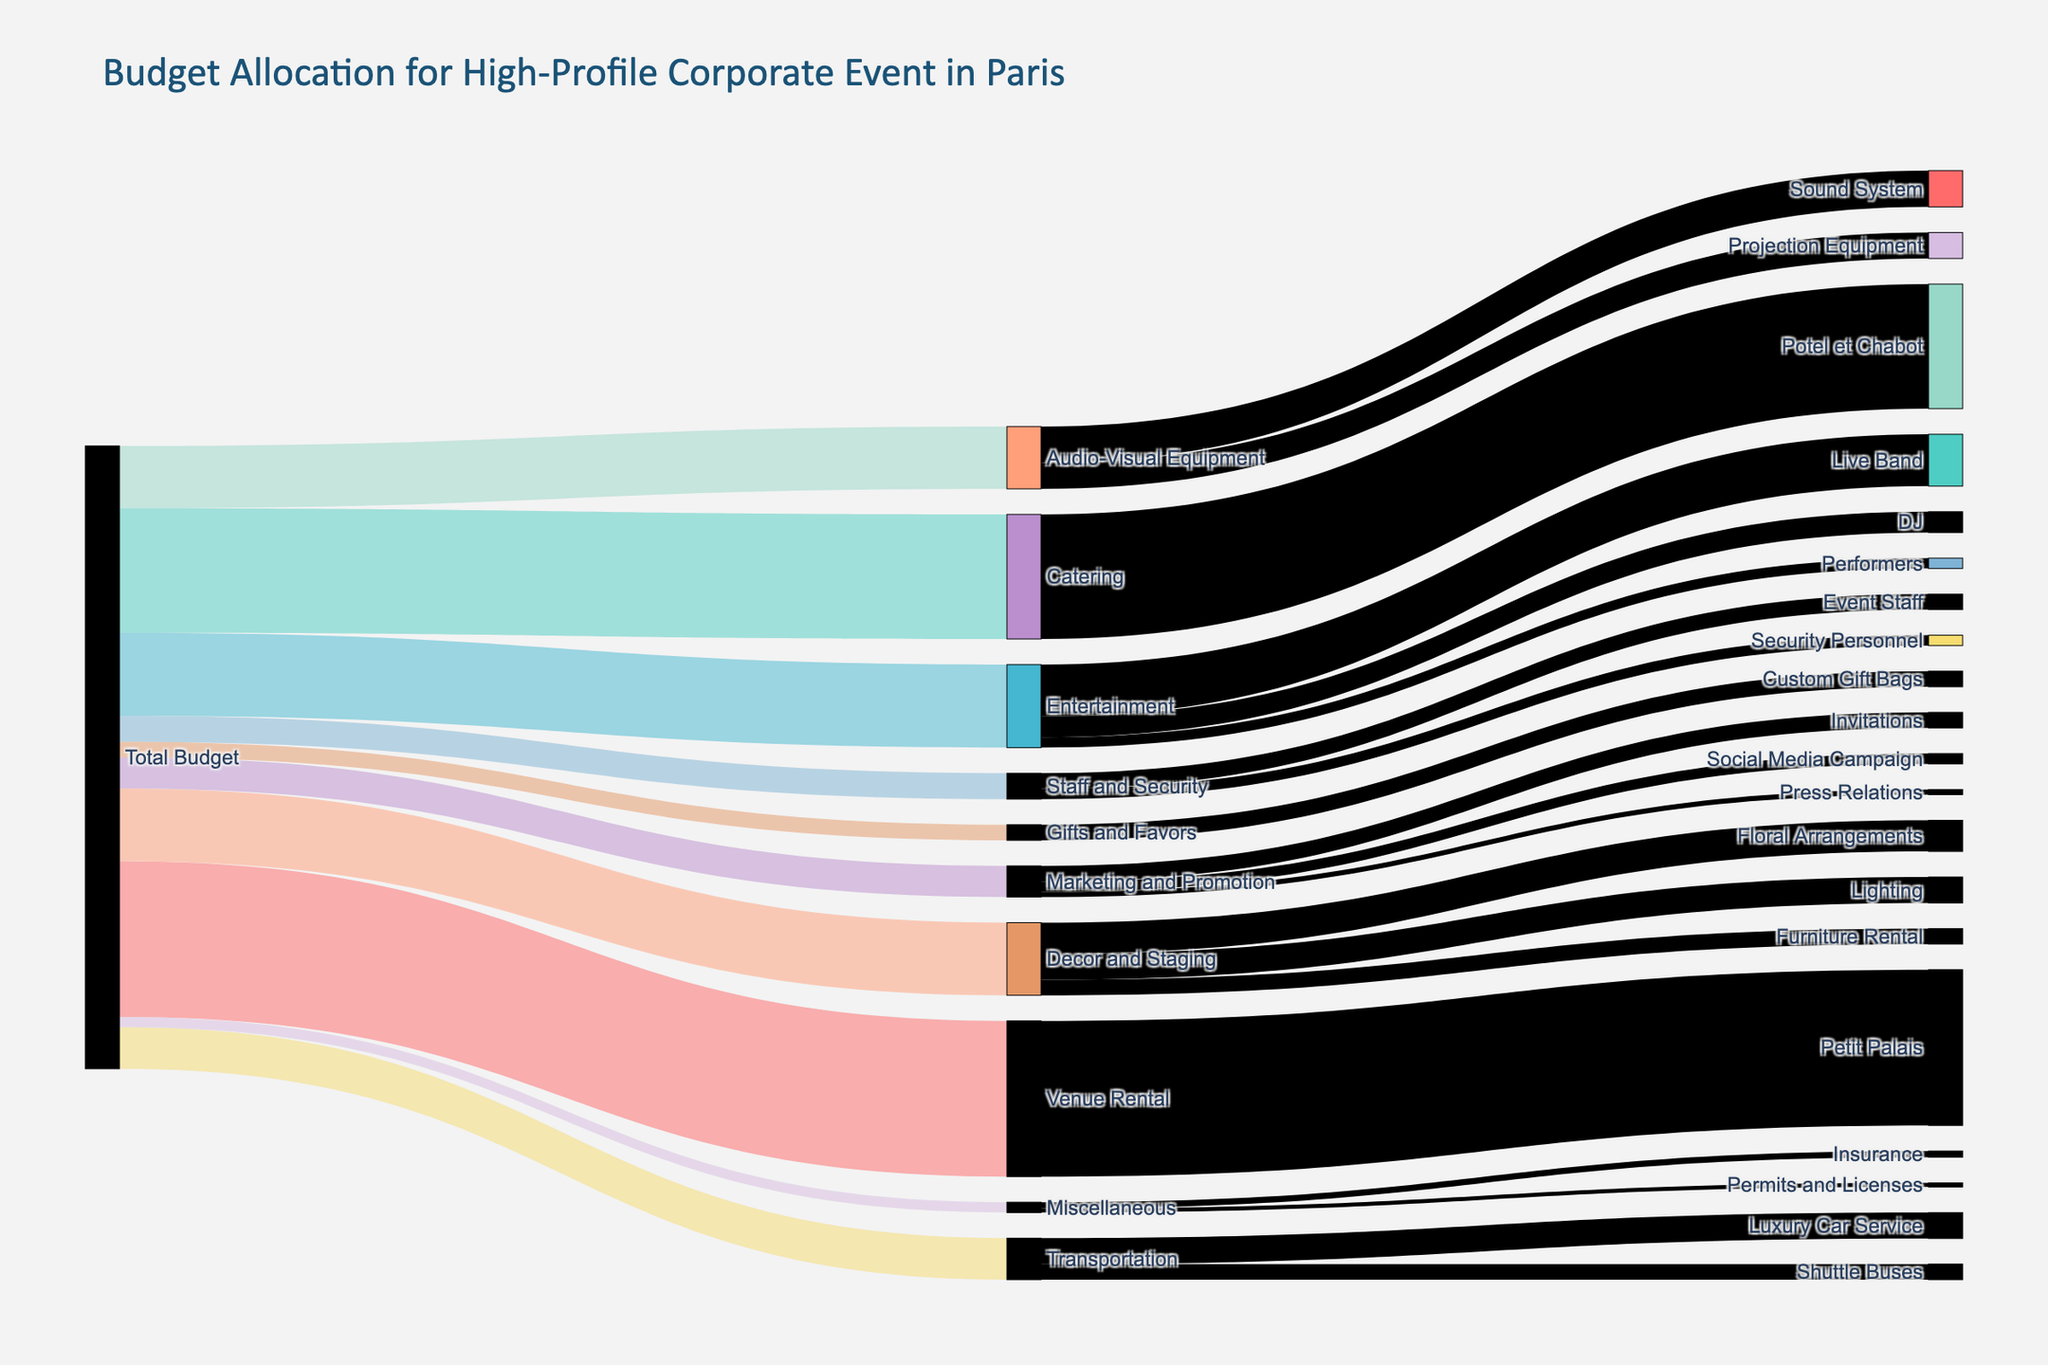What is the title of the diagram? The title is typically displayed at the top of the diagram. In this case, it tells us what the visualization is about.
Answer: Budget Allocation for High-Profile Corporate Event in Paris How much of the budget is allocated to Catering? Look for the link labeled "Catering" coming from "Total Budget" and check the value associated with it.
Answer: 120,000 Which category has the lowest budget allocation? Examine the values linked from "Total Budget" to find the smallest number.
Answer: Miscellaneous What is the combined budget for Entertainment categories altogether? Sum the values allocated to "Live Band," "DJ," and "Performers" under the Entertainment category: 50,000 + 20,000 + 10,000 = 80,000
Answer: 80,000 How much budget is allotted to Insurance within Miscellaneous? Look for the "Miscellaneous" category and check the allocation value for "Insurance."
Answer: 6,000 Which category has the highest allocation within Transportation? Compare the values allocated within the "Transportation" category: "Luxury Car Service" vs. "Shuttle Buses."
Answer: Luxury Car Service Compare the budget for Audio-Visual Equipment to Decor and Staging. Which one is greater and by how much? Find values for both categories linked from "Total Budget" and calculate the difference: 70,000 - 60,000 = 10,000. Since 70,000 is for Decor and Staging, it is greater.
Answer: Decor and Staging by 10,000 What percentage of the total budget is the Transportation category? Divide the Transportation budget by the total budget and multiply by 100: (40,000 / 600,000) * 100 = 6.67%.
Answer: 6.67% What is the budget for Press Relations under Marketing and Promotion? Look at the breakdown within the "Marketing and Promotion" category and find the value for "Press Relations."
Answer: 5,000 Identify two categories with equal budget allocations. Check the allocated values across different categories and find any two with the same value.
Answer: Event Staff and Marketing Invitations at 15,000 